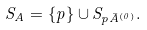<formula> <loc_0><loc_0><loc_500><loc_500>S _ { A } = \{ p \} \cup S _ { p \bar { A } ^ { ( 0 ) } } .</formula> 